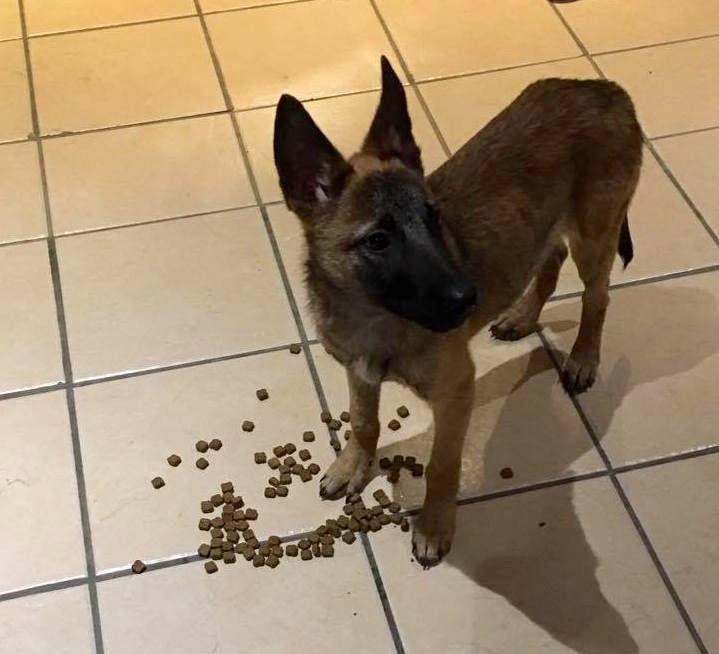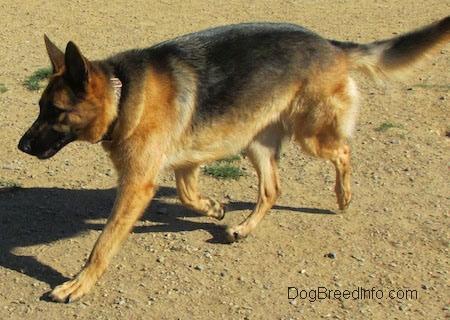The first image is the image on the left, the second image is the image on the right. For the images displayed, is the sentence "Each image contains one german shepherd, and the right image shows a dog moving toward the lower left." factually correct? Answer yes or no. Yes. The first image is the image on the left, the second image is the image on the right. For the images shown, is this caption "In one of the images, the dog is on a tile floor." true? Answer yes or no. Yes. 